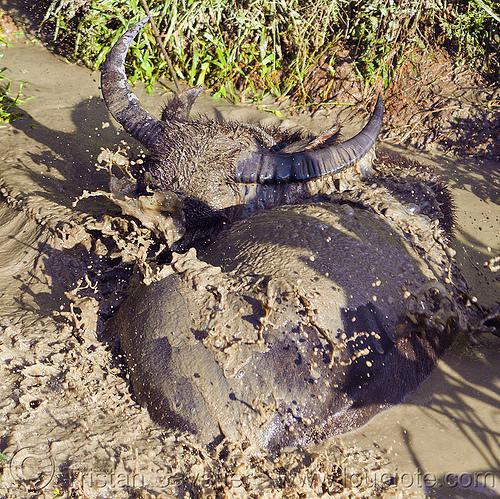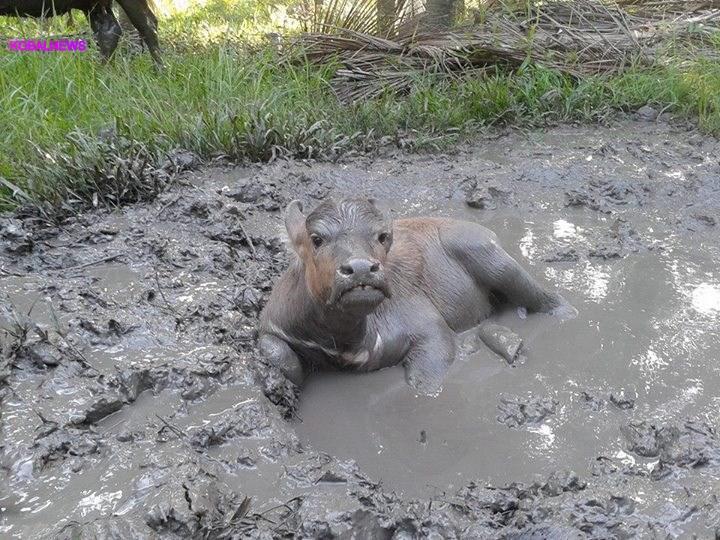The first image is the image on the left, the second image is the image on the right. Assess this claim about the two images: "An image shows exactly one water buffalo in a muddy pit, with its head turned forward.". Correct or not? Answer yes or no. Yes. The first image is the image on the left, the second image is the image on the right. Analyze the images presented: Is the assertion "There are at least four adult buffalos having a mud bath." valid? Answer yes or no. No. 